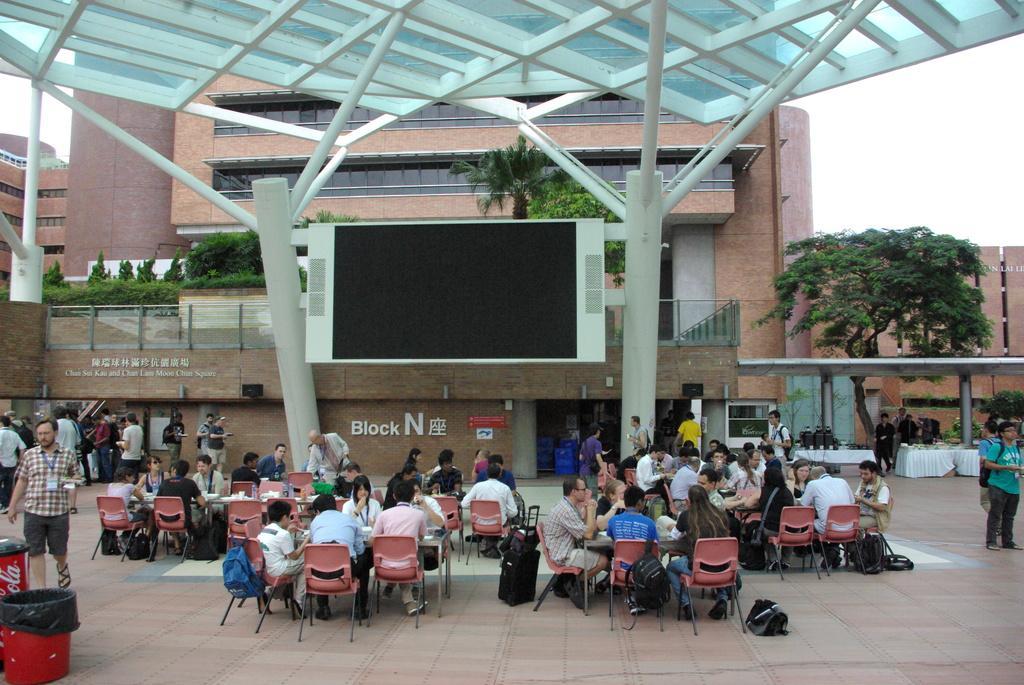Please provide a concise description of this image. Group of people sitting on chairs and few persons standing and we can see bins and bags on floor. On the background we can see buildings,persons,plants,trees and sky. 